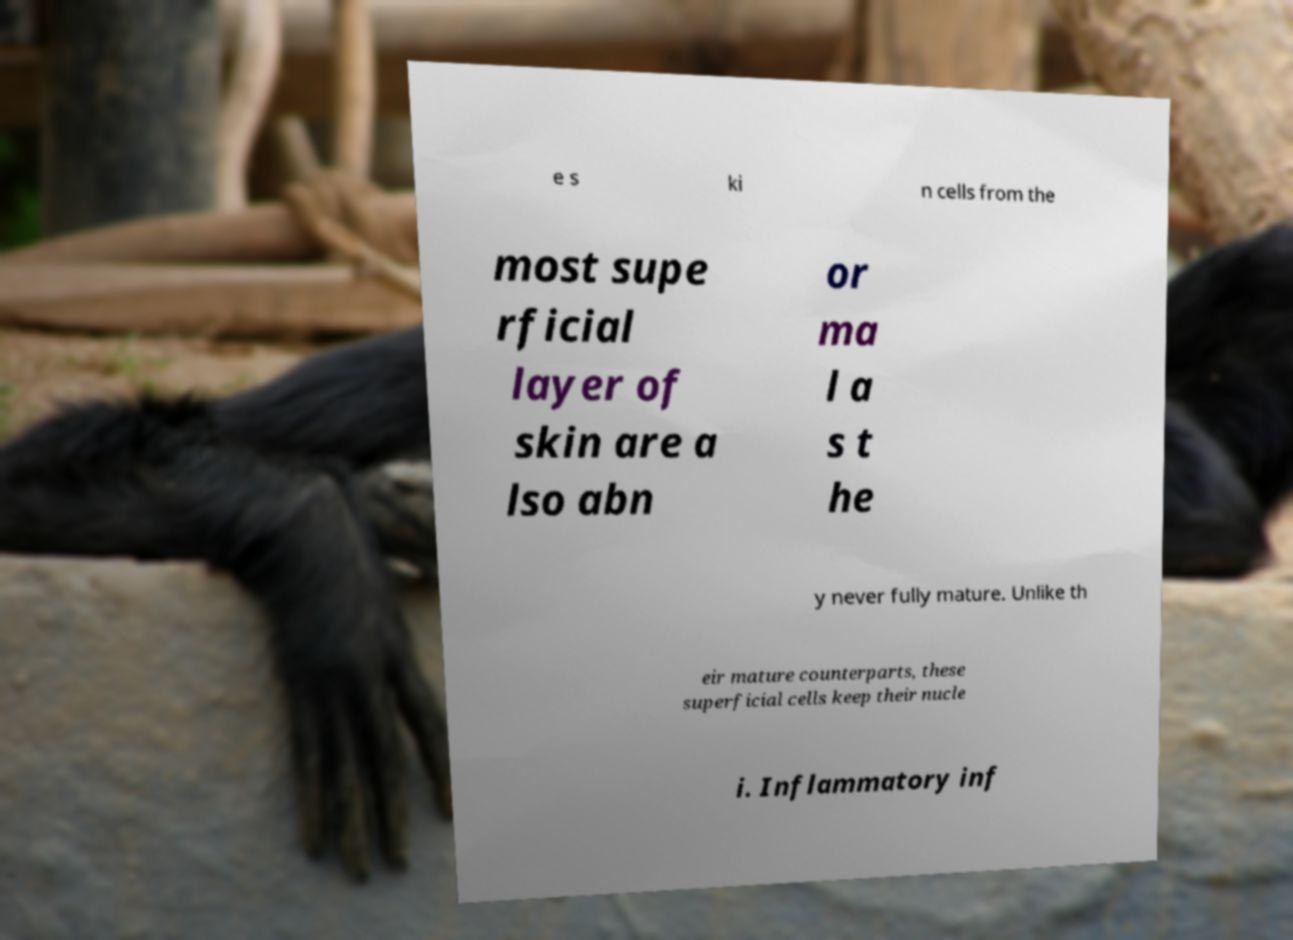Could you assist in decoding the text presented in this image and type it out clearly? e s ki n cells from the most supe rficial layer of skin are a lso abn or ma l a s t he y never fully mature. Unlike th eir mature counterparts, these superficial cells keep their nucle i. Inflammatory inf 